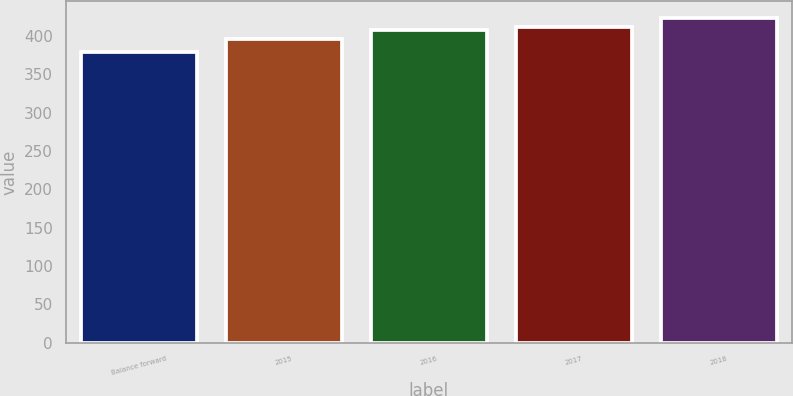Convert chart to OTSL. <chart><loc_0><loc_0><loc_500><loc_500><bar_chart><fcel>Balance forward<fcel>2015<fcel>2016<fcel>2017<fcel>2018<nl><fcel>379<fcel>396<fcel>408<fcel>412.5<fcel>424<nl></chart> 